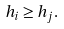<formula> <loc_0><loc_0><loc_500><loc_500>h _ { i } \geq h _ { j } .</formula> 